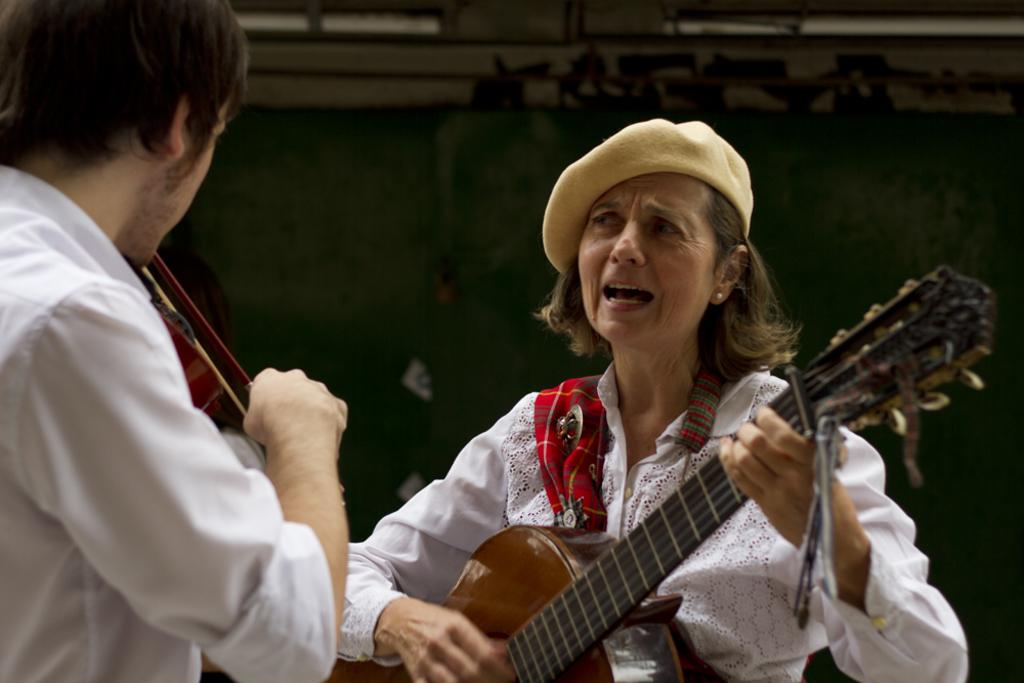Who is the main subject in the image? There is a woman in the image. What is the woman doing in the image? The woman is standing, singing a song, and playing a guitar. What is the woman wearing in the image? The woman is wearing a cap and a white dress. Who else is present in the image? There is a man in the image. What is the man doing in the image? The man is standing and playing a violin. What can be seen in the background of the image? The background of the image appears to be green. What type of farm animals can be seen in the image? There are no farm animals present in the image. 